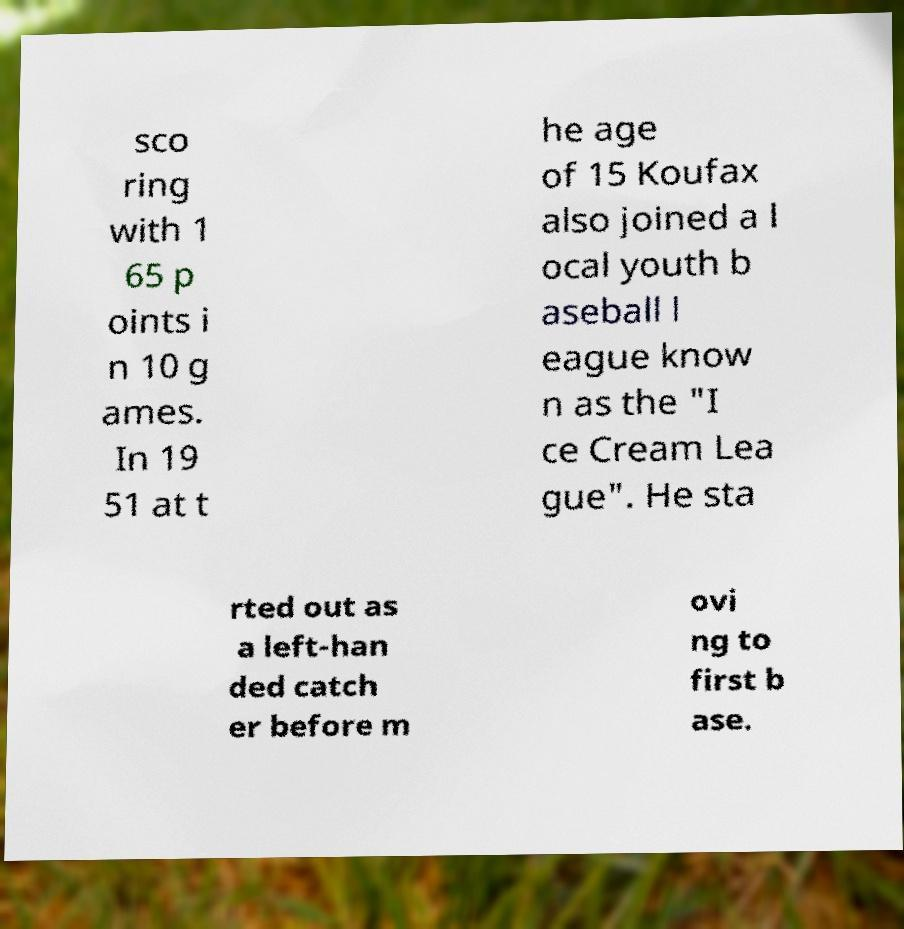What messages or text are displayed in this image? I need them in a readable, typed format. sco ring with 1 65 p oints i n 10 g ames. In 19 51 at t he age of 15 Koufax also joined a l ocal youth b aseball l eague know n as the "I ce Cream Lea gue". He sta rted out as a left-han ded catch er before m ovi ng to first b ase. 